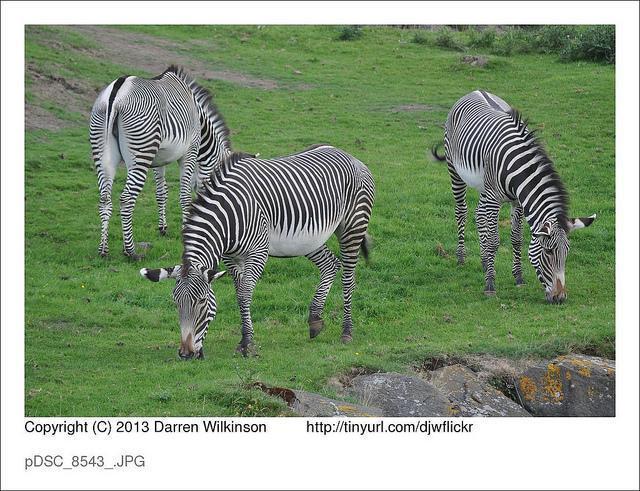How many alligators?
Give a very brief answer. 0. How many zebras are there?
Give a very brief answer. 3. 